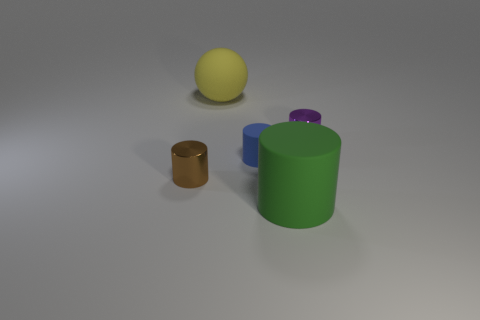Subtract all large cylinders. How many cylinders are left? 3 Add 2 brown metal things. How many objects exist? 7 Subtract all brown cylinders. How many cylinders are left? 3 Subtract all blue cubes. How many purple cylinders are left? 1 Subtract all red metallic spheres. Subtract all big things. How many objects are left? 3 Add 3 large yellow balls. How many large yellow balls are left? 4 Add 3 large red things. How many large red things exist? 3 Subtract 0 blue spheres. How many objects are left? 5 Subtract all balls. How many objects are left? 4 Subtract 4 cylinders. How many cylinders are left? 0 